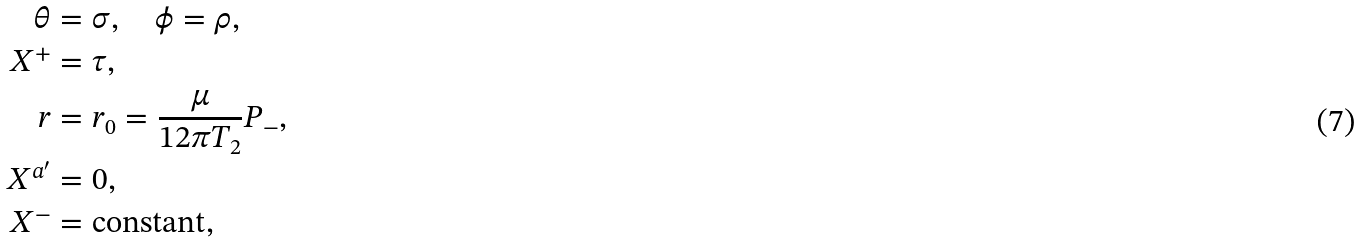Convert formula to latex. <formula><loc_0><loc_0><loc_500><loc_500>\theta & = \sigma , \quad \phi = \rho , \\ X ^ { + } & = \tau , \\ r & = r _ { 0 } = \frac { \mu } { 1 2 \pi T _ { 2 } } P _ { - } , \\ X ^ { a ^ { \prime } } & = 0 , \\ X ^ { - } & = \text {constant} ,</formula> 